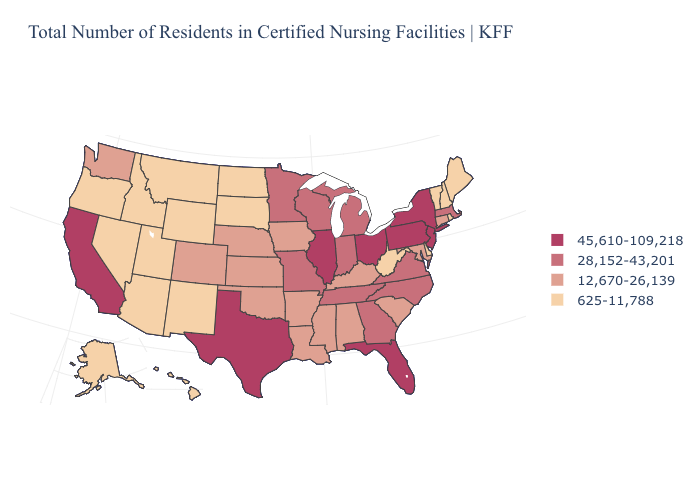Which states have the lowest value in the USA?
Be succinct. Alaska, Arizona, Delaware, Hawaii, Idaho, Maine, Montana, Nevada, New Hampshire, New Mexico, North Dakota, Oregon, Rhode Island, South Dakota, Utah, Vermont, West Virginia, Wyoming. What is the value of Utah?
Keep it brief. 625-11,788. Name the states that have a value in the range 12,670-26,139?
Answer briefly. Alabama, Arkansas, Colorado, Connecticut, Iowa, Kansas, Kentucky, Louisiana, Maryland, Mississippi, Nebraska, Oklahoma, South Carolina, Washington. Does Vermont have the lowest value in the Northeast?
Be succinct. Yes. What is the highest value in the USA?
Be succinct. 45,610-109,218. Does Massachusetts have a lower value than Ohio?
Answer briefly. Yes. Does Alabama have a higher value than South Dakota?
Give a very brief answer. Yes. What is the value of Missouri?
Quick response, please. 28,152-43,201. Name the states that have a value in the range 625-11,788?
Quick response, please. Alaska, Arizona, Delaware, Hawaii, Idaho, Maine, Montana, Nevada, New Hampshire, New Mexico, North Dakota, Oregon, Rhode Island, South Dakota, Utah, Vermont, West Virginia, Wyoming. What is the value of North Carolina?
Give a very brief answer. 28,152-43,201. What is the value of Wyoming?
Quick response, please. 625-11,788. What is the value of Arizona?
Short answer required. 625-11,788. Which states have the lowest value in the USA?
Give a very brief answer. Alaska, Arizona, Delaware, Hawaii, Idaho, Maine, Montana, Nevada, New Hampshire, New Mexico, North Dakota, Oregon, Rhode Island, South Dakota, Utah, Vermont, West Virginia, Wyoming. Does West Virginia have the same value as New Hampshire?
Keep it brief. Yes. What is the value of Alabama?
Write a very short answer. 12,670-26,139. 